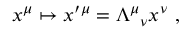<formula> <loc_0><loc_0><loc_500><loc_500>x ^ { \mu } \mapsto x ^ { \prime \mu } = { \Lambda ^ { \mu } } _ { \nu } x ^ { \nu } ,</formula> 